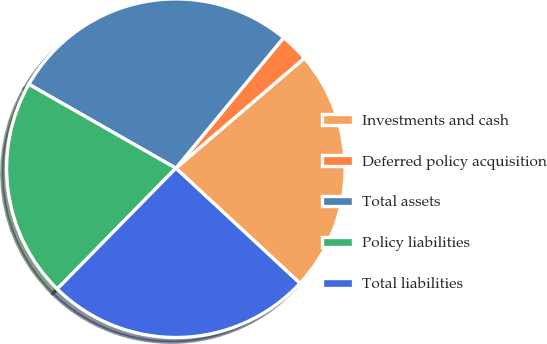Convert chart. <chart><loc_0><loc_0><loc_500><loc_500><pie_chart><fcel>Investments and cash<fcel>Deferred policy acquisition<fcel>Total assets<fcel>Policy liabilities<fcel>Total liabilities<nl><fcel>23.18%<fcel>2.74%<fcel>27.73%<fcel>20.9%<fcel>25.45%<nl></chart> 